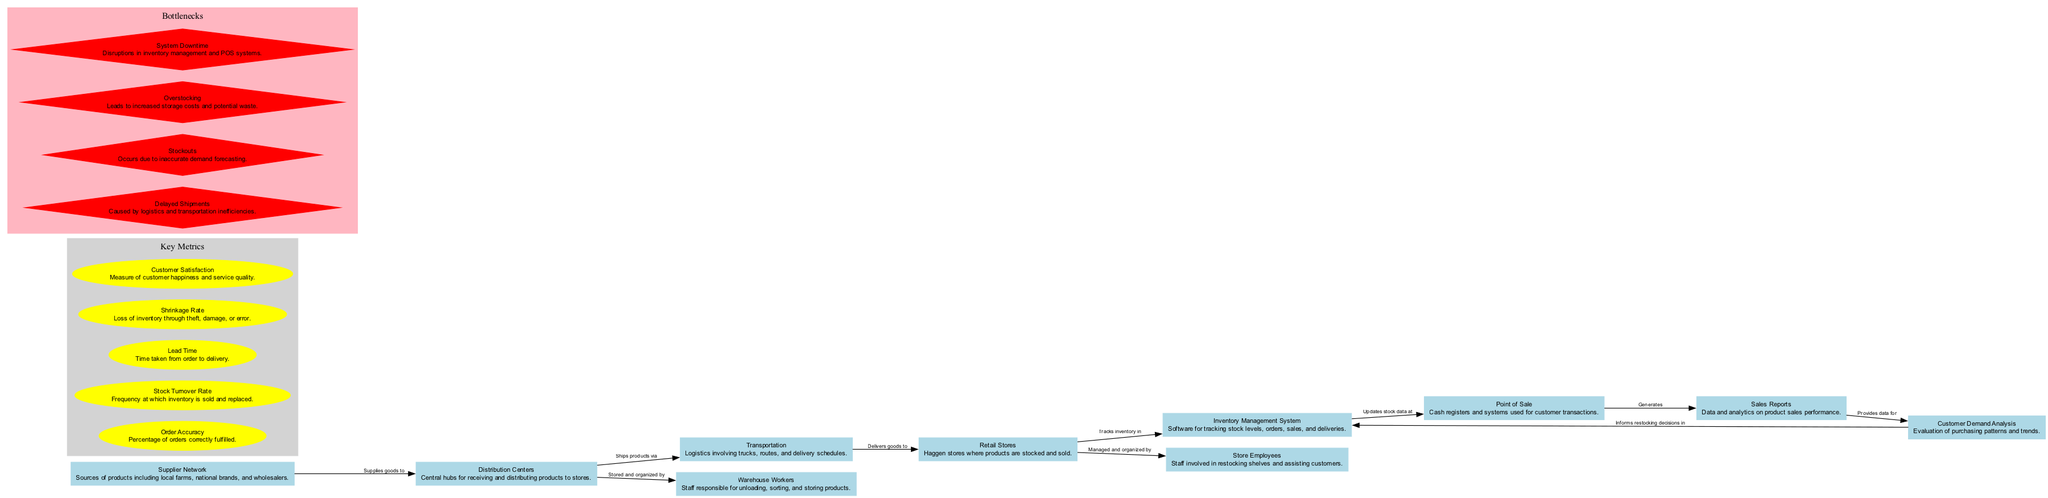What's the total number of nodes in the diagram? The diagram lists ten distinct nodes, each representing a component of the inventory management and supply chain process at Haggen.
Answer: 10 Which node is responsible for customer transactions? The "Point of Sale" node specifically indicates the cash registers and systems used for conducting customer transactions.
Answer: Point of Sale What connects Distribution Centers and Transportation? The relationship indicates that Distribution Centers "Ships products via" Transportation, highlighting how goods move from centers to retail.
Answer: Ships products via What is the metric related to the loss of inventory? The "Shrinkage Rate" metric quantifies the loss of inventory that occurs through theft, damage, or error.
Answer: Shrinkage Rate What bottleneck is caused by inaccuracies in demand forecasting? "Stockouts" occur when there's a mismatch between inventory levels and actual customer demand due to forecasting errors.
Answer: Stockouts Which nodes are involved in managing and organizing warehouse activities? The "Distribution Centers" and "Warehouse Workers" nodes are both involved, as the workers are responsible for storing and organizing the products received at these centers.
Answer: Distribution Centers and Warehouse Workers How do Sales Reports relate to Customer Demand Analysis? Sales Reports generate data that is utilized for conducting Customer Demand Analysis, allowing the store to evaluate purchasing patterns.
Answer: Provides data for What is the main reason for Delayed Shipments bottleneck? The Delayed Shipments bottleneck arises from "logistics and transportation inefficiencies" that impede timely deliveries of products.
Answer: Logistics and transportation inefficiencies In which node do inventory tracking activities take place? The "Inventory Management System" node is the one designated for tracking inventory levels, orders, sales, and deliveries.
Answer: Inventory Management System What is the benefit of analyzing Customer Demand? Customer Demand Analysis provides critical insights for informing restocking decisions in the Inventory Management System, ensuring shelves are stocked appropriately based on customer preferences.
Answer: Informs restocking decisions in 